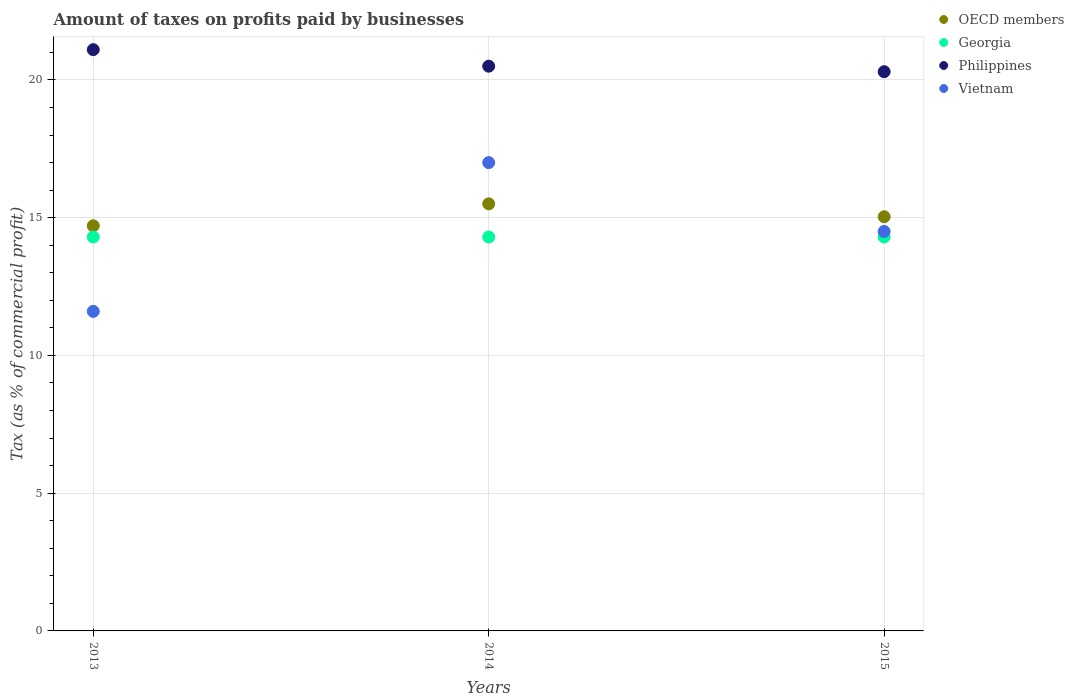How many different coloured dotlines are there?
Offer a terse response. 4. What is the percentage of taxes paid by businesses in Vietnam in 2014?
Provide a succinct answer. 17. Across all years, what is the maximum percentage of taxes paid by businesses in Philippines?
Offer a very short reply. 21.1. In which year was the percentage of taxes paid by businesses in Philippines minimum?
Ensure brevity in your answer.  2015. What is the total percentage of taxes paid by businesses in Georgia in the graph?
Give a very brief answer. 42.9. What is the difference between the percentage of taxes paid by businesses in OECD members in 2013 and that in 2015?
Provide a succinct answer. -0.33. What is the difference between the percentage of taxes paid by businesses in Philippines in 2013 and the percentage of taxes paid by businesses in Georgia in 2014?
Your answer should be compact. 6.8. What is the average percentage of taxes paid by businesses in Georgia per year?
Give a very brief answer. 14.3. In the year 2013, what is the difference between the percentage of taxes paid by businesses in Georgia and percentage of taxes paid by businesses in OECD members?
Your response must be concise. -0.41. In how many years, is the percentage of taxes paid by businesses in Philippines greater than 18 %?
Keep it short and to the point. 3. What is the ratio of the percentage of taxes paid by businesses in Vietnam in 2013 to that in 2014?
Your response must be concise. 0.68. Is the percentage of taxes paid by businesses in OECD members in 2013 less than that in 2015?
Keep it short and to the point. Yes. Is the difference between the percentage of taxes paid by businesses in Georgia in 2013 and 2014 greater than the difference between the percentage of taxes paid by businesses in OECD members in 2013 and 2014?
Ensure brevity in your answer.  Yes. What is the difference between the highest and the second highest percentage of taxes paid by businesses in OECD members?
Provide a short and direct response. 0.47. What is the difference between the highest and the lowest percentage of taxes paid by businesses in OECD members?
Your answer should be very brief. 0.8. In how many years, is the percentage of taxes paid by businesses in Vietnam greater than the average percentage of taxes paid by businesses in Vietnam taken over all years?
Your answer should be compact. 2. Is it the case that in every year, the sum of the percentage of taxes paid by businesses in Vietnam and percentage of taxes paid by businesses in Georgia  is greater than the percentage of taxes paid by businesses in OECD members?
Offer a very short reply. Yes. Does the percentage of taxes paid by businesses in Philippines monotonically increase over the years?
Your answer should be compact. No. Is the percentage of taxes paid by businesses in Georgia strictly greater than the percentage of taxes paid by businesses in Philippines over the years?
Your answer should be very brief. No. Does the graph contain grids?
Provide a succinct answer. Yes. How many legend labels are there?
Ensure brevity in your answer.  4. What is the title of the graph?
Your answer should be compact. Amount of taxes on profits paid by businesses. What is the label or title of the X-axis?
Your response must be concise. Years. What is the label or title of the Y-axis?
Give a very brief answer. Tax (as % of commercial profit). What is the Tax (as % of commercial profit) in OECD members in 2013?
Give a very brief answer. 14.71. What is the Tax (as % of commercial profit) in Philippines in 2013?
Your response must be concise. 21.1. What is the Tax (as % of commercial profit) of OECD members in 2014?
Your response must be concise. 15.5. What is the Tax (as % of commercial profit) of Vietnam in 2014?
Make the answer very short. 17. What is the Tax (as % of commercial profit) in OECD members in 2015?
Provide a short and direct response. 15.04. What is the Tax (as % of commercial profit) in Georgia in 2015?
Offer a terse response. 14.3. What is the Tax (as % of commercial profit) in Philippines in 2015?
Keep it short and to the point. 20.3. Across all years, what is the maximum Tax (as % of commercial profit) of OECD members?
Keep it short and to the point. 15.5. Across all years, what is the maximum Tax (as % of commercial profit) in Philippines?
Make the answer very short. 21.1. Across all years, what is the minimum Tax (as % of commercial profit) of OECD members?
Provide a succinct answer. 14.71. Across all years, what is the minimum Tax (as % of commercial profit) of Georgia?
Keep it short and to the point. 14.3. Across all years, what is the minimum Tax (as % of commercial profit) of Philippines?
Provide a succinct answer. 20.3. What is the total Tax (as % of commercial profit) of OECD members in the graph?
Offer a terse response. 45.25. What is the total Tax (as % of commercial profit) in Georgia in the graph?
Your response must be concise. 42.9. What is the total Tax (as % of commercial profit) in Philippines in the graph?
Offer a very short reply. 61.9. What is the total Tax (as % of commercial profit) in Vietnam in the graph?
Make the answer very short. 43.1. What is the difference between the Tax (as % of commercial profit) of OECD members in 2013 and that in 2014?
Provide a short and direct response. -0.8. What is the difference between the Tax (as % of commercial profit) of Vietnam in 2013 and that in 2014?
Ensure brevity in your answer.  -5.4. What is the difference between the Tax (as % of commercial profit) of OECD members in 2013 and that in 2015?
Provide a succinct answer. -0.33. What is the difference between the Tax (as % of commercial profit) of Georgia in 2013 and that in 2015?
Your answer should be very brief. 0. What is the difference between the Tax (as % of commercial profit) in Philippines in 2013 and that in 2015?
Offer a terse response. 0.8. What is the difference between the Tax (as % of commercial profit) of Vietnam in 2013 and that in 2015?
Give a very brief answer. -2.9. What is the difference between the Tax (as % of commercial profit) in OECD members in 2014 and that in 2015?
Offer a very short reply. 0.47. What is the difference between the Tax (as % of commercial profit) of Georgia in 2014 and that in 2015?
Ensure brevity in your answer.  0. What is the difference between the Tax (as % of commercial profit) of Philippines in 2014 and that in 2015?
Keep it short and to the point. 0.2. What is the difference between the Tax (as % of commercial profit) in OECD members in 2013 and the Tax (as % of commercial profit) in Georgia in 2014?
Offer a terse response. 0.41. What is the difference between the Tax (as % of commercial profit) in OECD members in 2013 and the Tax (as % of commercial profit) in Philippines in 2014?
Your answer should be very brief. -5.79. What is the difference between the Tax (as % of commercial profit) of OECD members in 2013 and the Tax (as % of commercial profit) of Vietnam in 2014?
Provide a short and direct response. -2.29. What is the difference between the Tax (as % of commercial profit) in Philippines in 2013 and the Tax (as % of commercial profit) in Vietnam in 2014?
Keep it short and to the point. 4.1. What is the difference between the Tax (as % of commercial profit) of OECD members in 2013 and the Tax (as % of commercial profit) of Georgia in 2015?
Provide a short and direct response. 0.41. What is the difference between the Tax (as % of commercial profit) of OECD members in 2013 and the Tax (as % of commercial profit) of Philippines in 2015?
Your response must be concise. -5.59. What is the difference between the Tax (as % of commercial profit) of OECD members in 2013 and the Tax (as % of commercial profit) of Vietnam in 2015?
Your response must be concise. 0.21. What is the difference between the Tax (as % of commercial profit) of Georgia in 2013 and the Tax (as % of commercial profit) of Philippines in 2015?
Make the answer very short. -6. What is the difference between the Tax (as % of commercial profit) of Philippines in 2013 and the Tax (as % of commercial profit) of Vietnam in 2015?
Your answer should be very brief. 6.6. What is the difference between the Tax (as % of commercial profit) of OECD members in 2014 and the Tax (as % of commercial profit) of Georgia in 2015?
Your response must be concise. 1.2. What is the difference between the Tax (as % of commercial profit) of OECD members in 2014 and the Tax (as % of commercial profit) of Philippines in 2015?
Your answer should be compact. -4.8. What is the average Tax (as % of commercial profit) of OECD members per year?
Your answer should be very brief. 15.08. What is the average Tax (as % of commercial profit) of Georgia per year?
Provide a short and direct response. 14.3. What is the average Tax (as % of commercial profit) of Philippines per year?
Your response must be concise. 20.63. What is the average Tax (as % of commercial profit) of Vietnam per year?
Give a very brief answer. 14.37. In the year 2013, what is the difference between the Tax (as % of commercial profit) of OECD members and Tax (as % of commercial profit) of Georgia?
Offer a terse response. 0.41. In the year 2013, what is the difference between the Tax (as % of commercial profit) in OECD members and Tax (as % of commercial profit) in Philippines?
Provide a short and direct response. -6.39. In the year 2013, what is the difference between the Tax (as % of commercial profit) in OECD members and Tax (as % of commercial profit) in Vietnam?
Keep it short and to the point. 3.11. In the year 2013, what is the difference between the Tax (as % of commercial profit) of Georgia and Tax (as % of commercial profit) of Vietnam?
Provide a short and direct response. 2.7. In the year 2013, what is the difference between the Tax (as % of commercial profit) in Philippines and Tax (as % of commercial profit) in Vietnam?
Provide a short and direct response. 9.5. In the year 2014, what is the difference between the Tax (as % of commercial profit) of OECD members and Tax (as % of commercial profit) of Georgia?
Offer a very short reply. 1.2. In the year 2014, what is the difference between the Tax (as % of commercial profit) of OECD members and Tax (as % of commercial profit) of Philippines?
Provide a succinct answer. -5. In the year 2014, what is the difference between the Tax (as % of commercial profit) in OECD members and Tax (as % of commercial profit) in Vietnam?
Your answer should be compact. -1.5. In the year 2015, what is the difference between the Tax (as % of commercial profit) of OECD members and Tax (as % of commercial profit) of Georgia?
Give a very brief answer. 0.74. In the year 2015, what is the difference between the Tax (as % of commercial profit) of OECD members and Tax (as % of commercial profit) of Philippines?
Keep it short and to the point. -5.26. In the year 2015, what is the difference between the Tax (as % of commercial profit) of OECD members and Tax (as % of commercial profit) of Vietnam?
Your response must be concise. 0.54. In the year 2015, what is the difference between the Tax (as % of commercial profit) in Georgia and Tax (as % of commercial profit) in Philippines?
Make the answer very short. -6. In the year 2015, what is the difference between the Tax (as % of commercial profit) in Philippines and Tax (as % of commercial profit) in Vietnam?
Your answer should be compact. 5.8. What is the ratio of the Tax (as % of commercial profit) in OECD members in 2013 to that in 2014?
Ensure brevity in your answer.  0.95. What is the ratio of the Tax (as % of commercial profit) of Georgia in 2013 to that in 2014?
Provide a succinct answer. 1. What is the ratio of the Tax (as % of commercial profit) in Philippines in 2013 to that in 2014?
Make the answer very short. 1.03. What is the ratio of the Tax (as % of commercial profit) in Vietnam in 2013 to that in 2014?
Provide a succinct answer. 0.68. What is the ratio of the Tax (as % of commercial profit) in OECD members in 2013 to that in 2015?
Provide a succinct answer. 0.98. What is the ratio of the Tax (as % of commercial profit) of Georgia in 2013 to that in 2015?
Your response must be concise. 1. What is the ratio of the Tax (as % of commercial profit) in Philippines in 2013 to that in 2015?
Your answer should be very brief. 1.04. What is the ratio of the Tax (as % of commercial profit) in OECD members in 2014 to that in 2015?
Your response must be concise. 1.03. What is the ratio of the Tax (as % of commercial profit) in Georgia in 2014 to that in 2015?
Give a very brief answer. 1. What is the ratio of the Tax (as % of commercial profit) in Philippines in 2014 to that in 2015?
Your answer should be compact. 1.01. What is the ratio of the Tax (as % of commercial profit) in Vietnam in 2014 to that in 2015?
Offer a terse response. 1.17. What is the difference between the highest and the second highest Tax (as % of commercial profit) of OECD members?
Provide a short and direct response. 0.47. What is the difference between the highest and the second highest Tax (as % of commercial profit) in Georgia?
Your response must be concise. 0. What is the difference between the highest and the lowest Tax (as % of commercial profit) of OECD members?
Offer a very short reply. 0.8. What is the difference between the highest and the lowest Tax (as % of commercial profit) of Georgia?
Provide a succinct answer. 0. What is the difference between the highest and the lowest Tax (as % of commercial profit) in Vietnam?
Your answer should be compact. 5.4. 